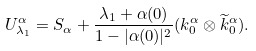Convert formula to latex. <formula><loc_0><loc_0><loc_500><loc_500>U _ { \lambda _ { 1 } } ^ { \alpha } = S _ { \alpha } + \frac { \lambda _ { 1 } + \alpha ( 0 ) } { 1 - | \alpha ( 0 ) | ^ { 2 } } ( k _ { 0 } ^ { \alpha } \otimes \widetilde { k } _ { 0 } ^ { \alpha } ) .</formula> 